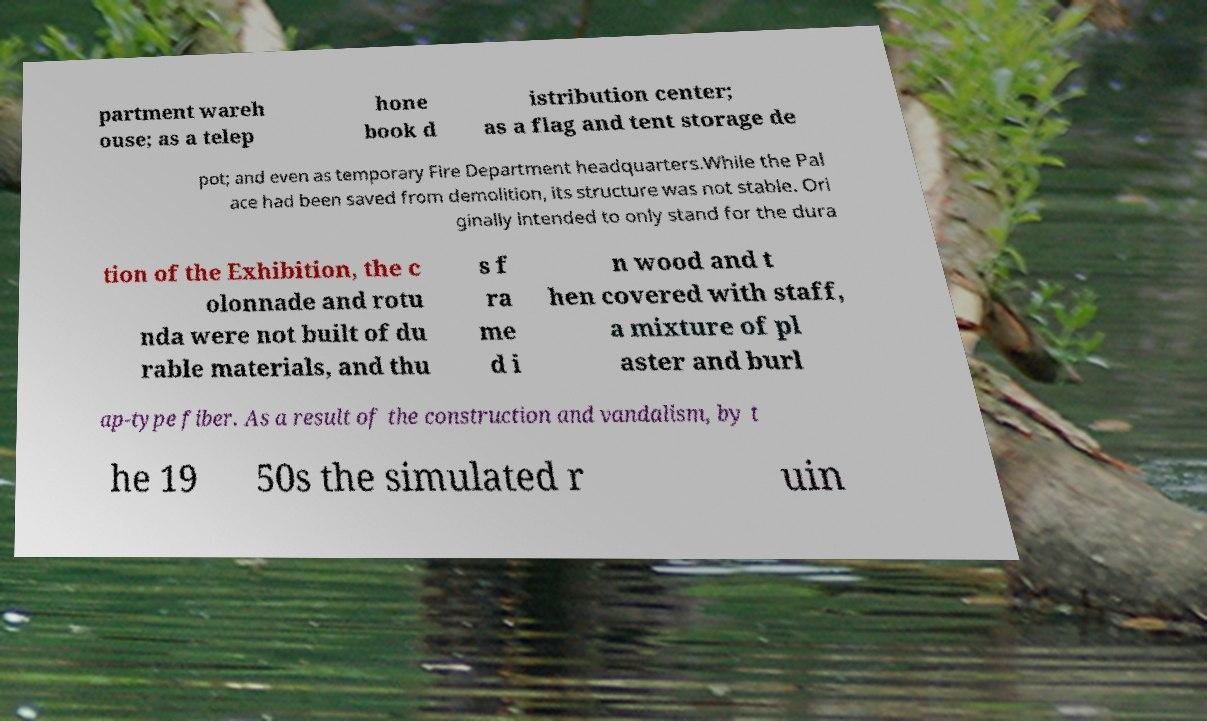I need the written content from this picture converted into text. Can you do that? partment wareh ouse; as a telep hone book d istribution center; as a flag and tent storage de pot; and even as temporary Fire Department headquarters.While the Pal ace had been saved from demolition, its structure was not stable. Ori ginally intended to only stand for the dura tion of the Exhibition, the c olonnade and rotu nda were not built of du rable materials, and thu s f ra me d i n wood and t hen covered with staff, a mixture of pl aster and burl ap-type fiber. As a result of the construction and vandalism, by t he 19 50s the simulated r uin 